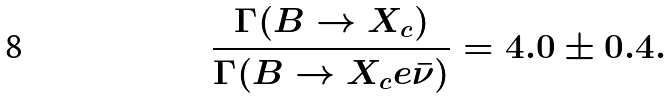Convert formula to latex. <formula><loc_0><loc_0><loc_500><loc_500>\frac { \Gamma ( B \to X _ { c } ) } { \Gamma ( B \to X _ { c } e \bar { \nu } ) } = 4 . 0 \pm 0 . 4 .</formula> 